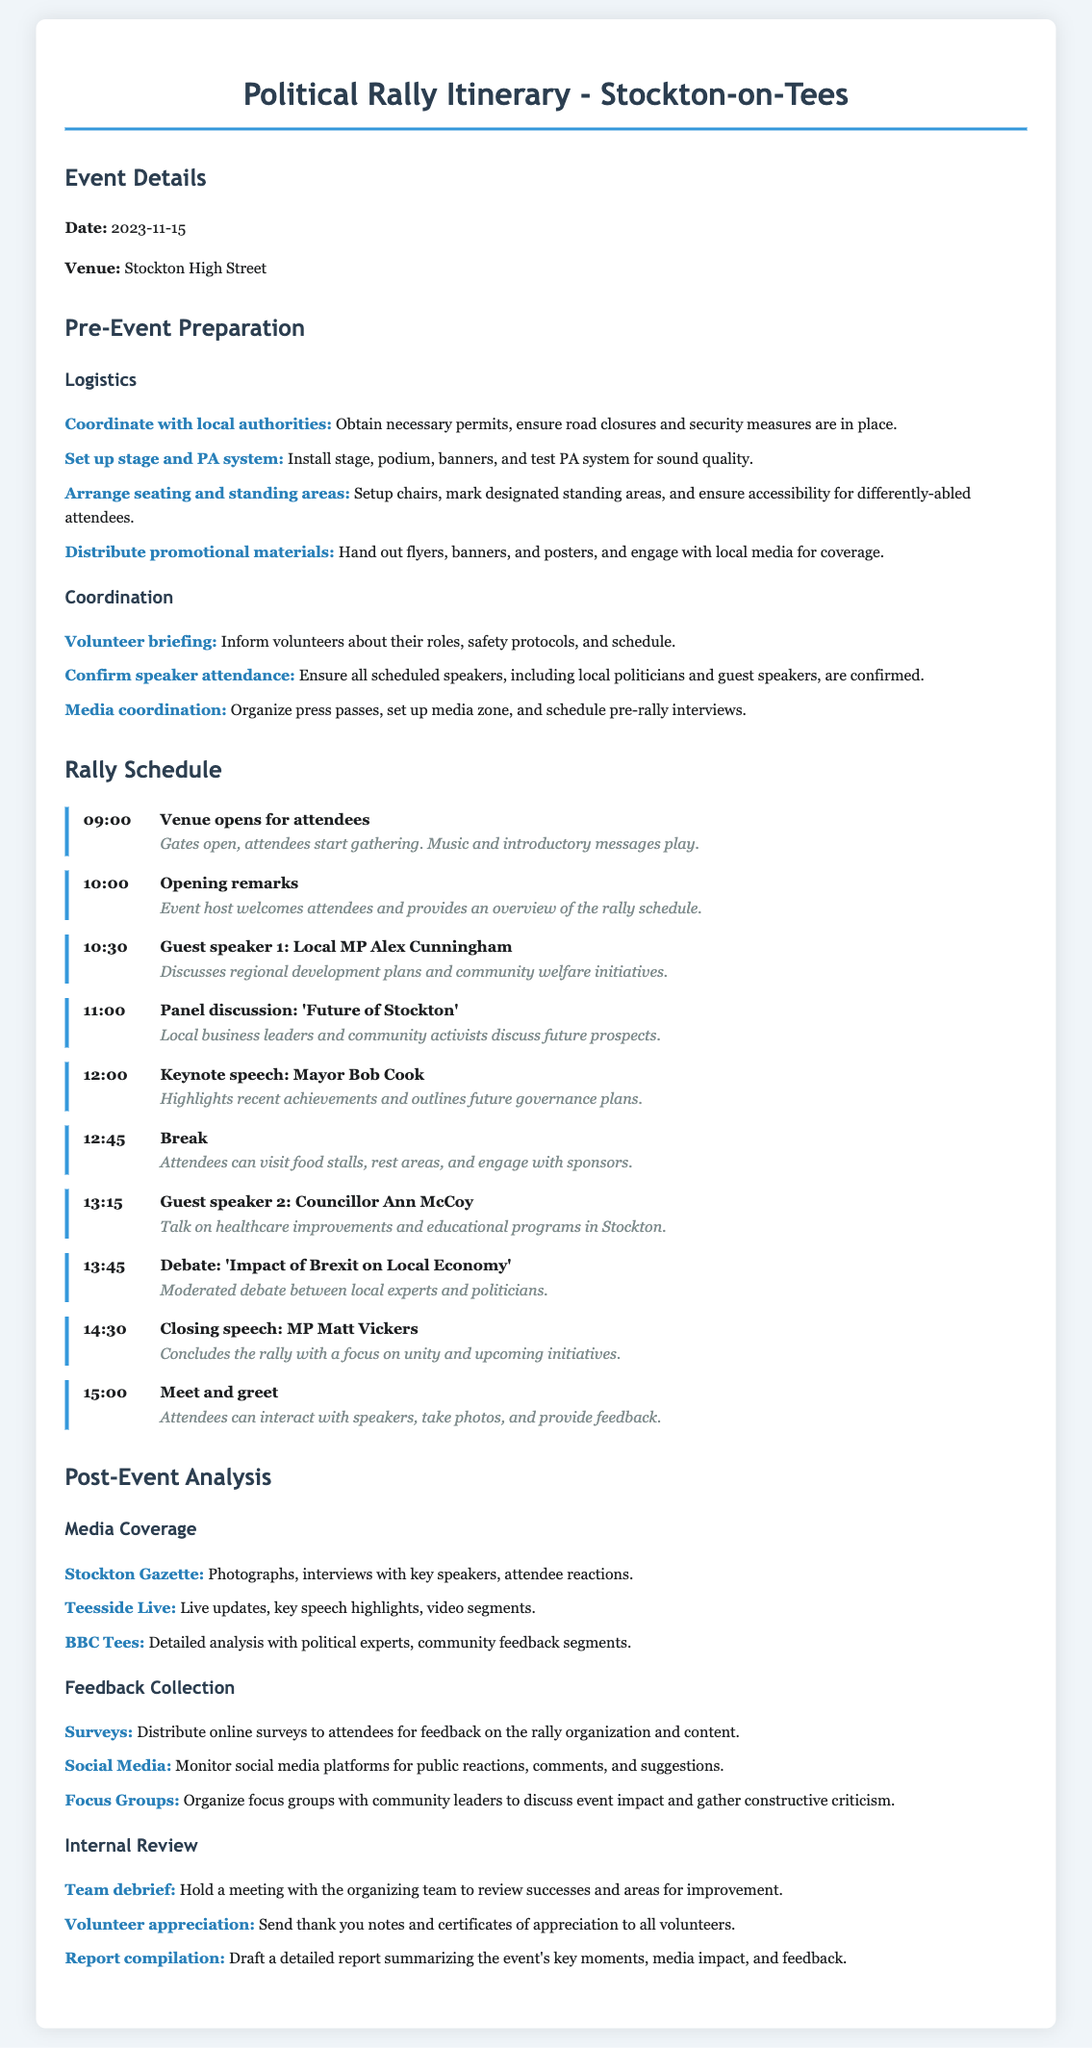What is the date of the rally? The date is specified in the document under Event Details.
Answer: 2023-11-15 What is the venue for the political rally? The venue is listed under Event Details.
Answer: Stockton High Street Who is the first guest speaker? The first guest speaker's name and time are provided in the Rally Schedule section.
Answer: Local MP Alex Cunningham At what time does the venue open for attendees? The time is noted in the Rally Schedule section.
Answer: 09:00 What topic will be discussed during the panel discussion? The topic is mentioned in the details of the scheduled activities.
Answer: Future of Stockton How long is the break scheduled for? The schedule indicates the start and end times around the break.
Answer: 45 minutes What type of media coverage is anticipated post-event? The document outlines different media outlets covering the rally in the Post-Event Analysis section.
Answer: Photographs, interviews, live updates What is one method for feedback collection mentioned? The document specifies various methods to collect feedback in the Post-Event Analysis section.
Answer: Surveys How will the organizing team review the event? The method is described in the Internal Review subsection of Post-Event Analysis.
Answer: Team debrief 